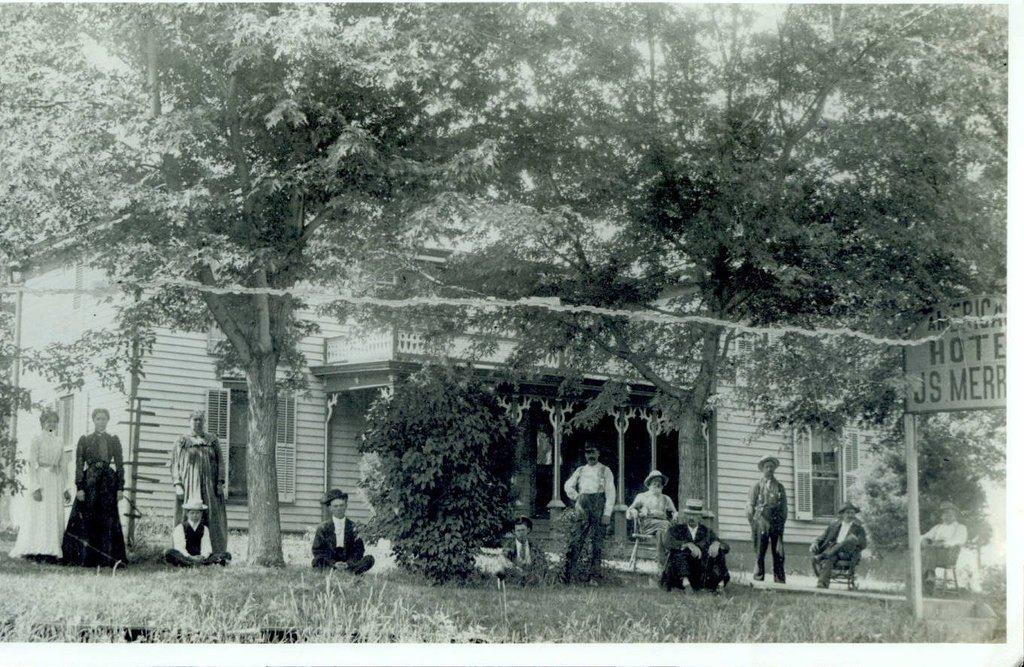What are the people in the image doing? The persons in the image are sitting and standing on the grass. What can be seen in the sky in the image? The sky is visible in the image. What type of vegetation is present in the image? There are trees in the image. Can any structures be identified in the image? Yes, there is at least one building present in the image. What part of the building is visible in the image? Windows are present in the image. What other objects can be seen in the image? Poles and an advertisement board are visible in the image. How many kittens are playing on the country road in the image? There are no kittens or country roads present in the image. What type of men are depicted on the advertisement board in the image? There is no advertisement board featuring men in the image. 